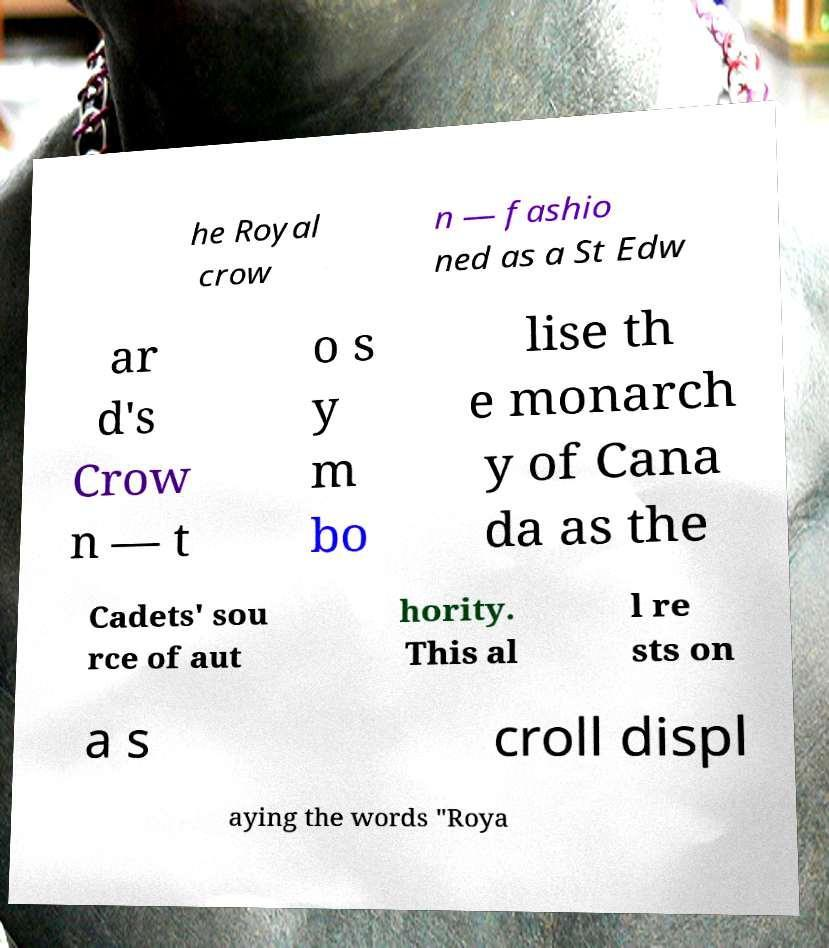There's text embedded in this image that I need extracted. Can you transcribe it verbatim? he Royal crow n — fashio ned as a St Edw ar d's Crow n — t o s y m bo lise th e monarch y of Cana da as the Cadets' sou rce of aut hority. This al l re sts on a s croll displ aying the words "Roya 